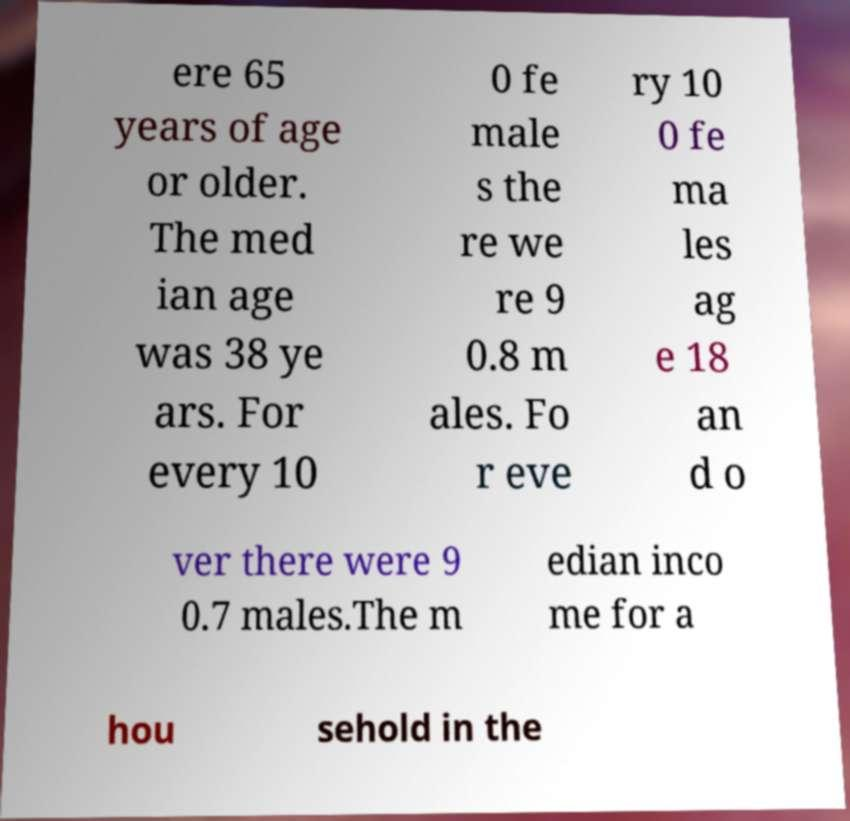Can you accurately transcribe the text from the provided image for me? ere 65 years of age or older. The med ian age was 38 ye ars. For every 10 0 fe male s the re we re 9 0.8 m ales. Fo r eve ry 10 0 fe ma les ag e 18 an d o ver there were 9 0.7 males.The m edian inco me for a hou sehold in the 